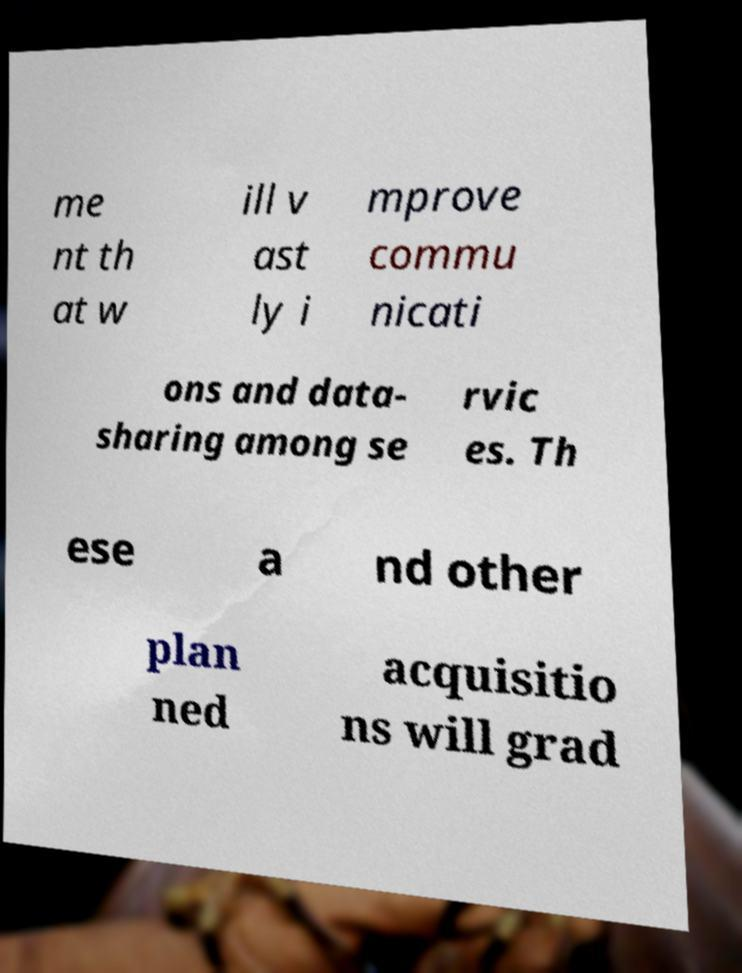There's text embedded in this image that I need extracted. Can you transcribe it verbatim? me nt th at w ill v ast ly i mprove commu nicati ons and data- sharing among se rvic es. Th ese a nd other plan ned acquisitio ns will grad 